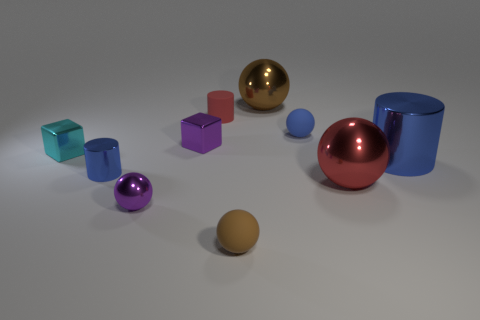Subtract all tiny blue cylinders. How many cylinders are left? 2 Subtract all red cylinders. How many cylinders are left? 2 Subtract 1 balls. How many balls are left? 4 Subtract all cylinders. How many objects are left? 7 Add 6 purple cubes. How many purple cubes are left? 7 Add 6 red balls. How many red balls exist? 7 Subtract 0 cyan spheres. How many objects are left? 10 Subtract all red blocks. Subtract all cyan spheres. How many blocks are left? 2 Subtract all brown balls. How many brown cylinders are left? 0 Subtract all tiny red matte things. Subtract all matte cylinders. How many objects are left? 8 